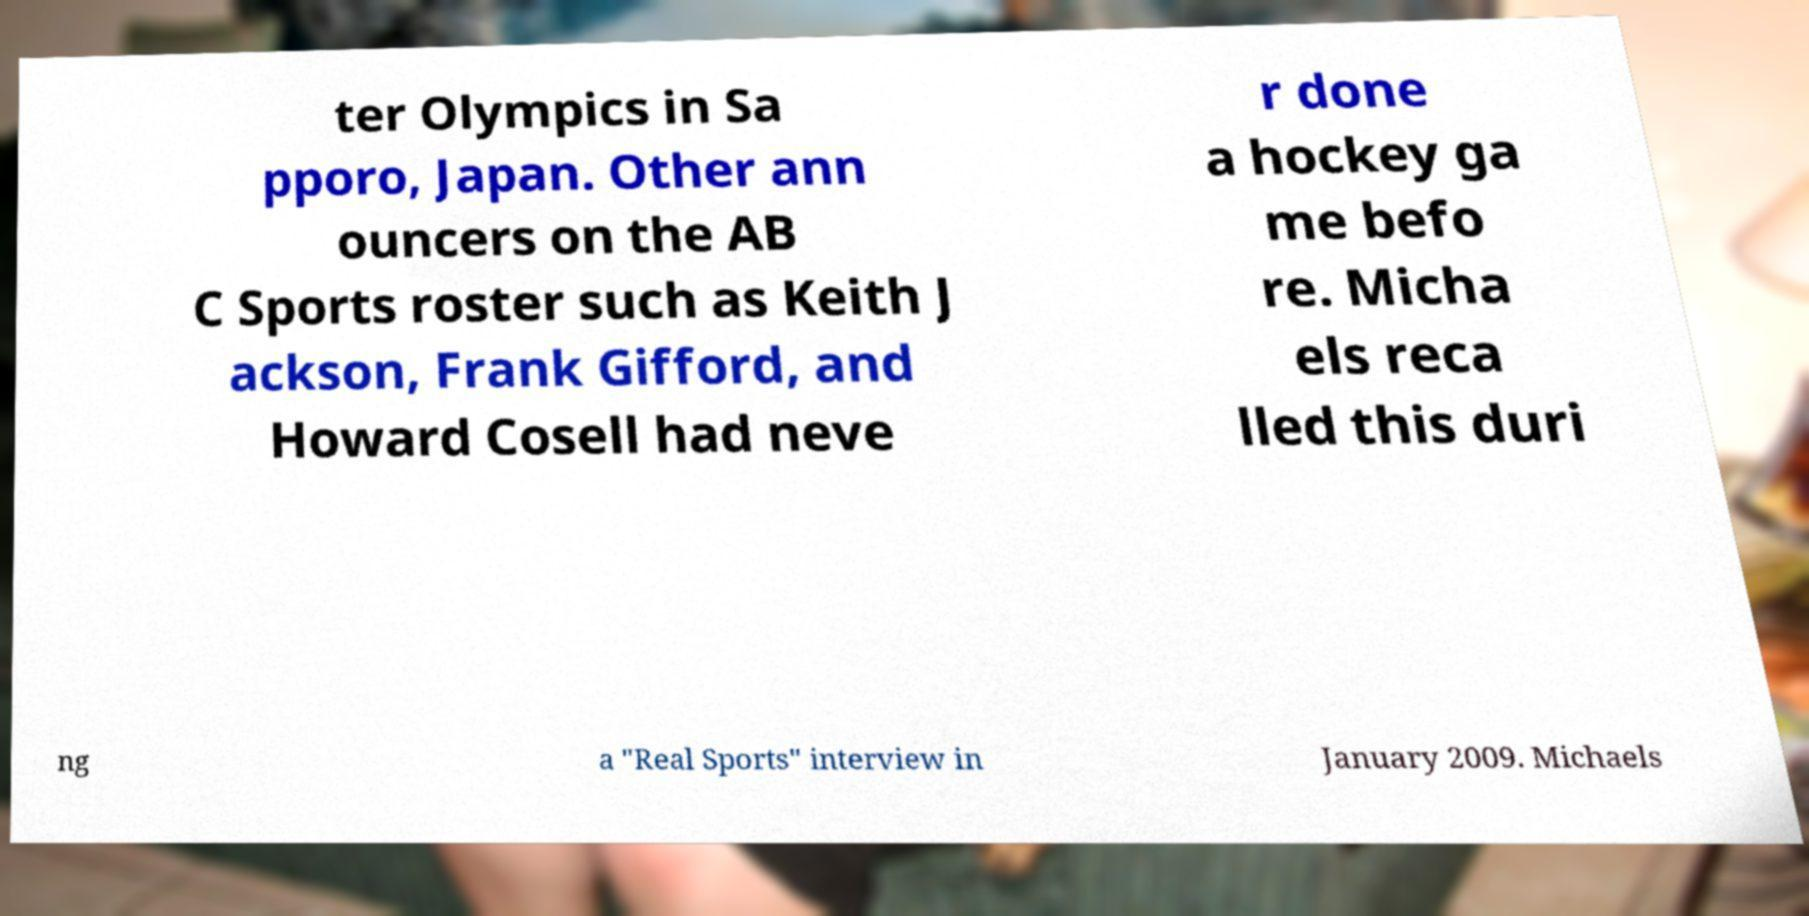I need the written content from this picture converted into text. Can you do that? ter Olympics in Sa pporo, Japan. Other ann ouncers on the AB C Sports roster such as Keith J ackson, Frank Gifford, and Howard Cosell had neve r done a hockey ga me befo re. Micha els reca lled this duri ng a "Real Sports" interview in January 2009. Michaels 